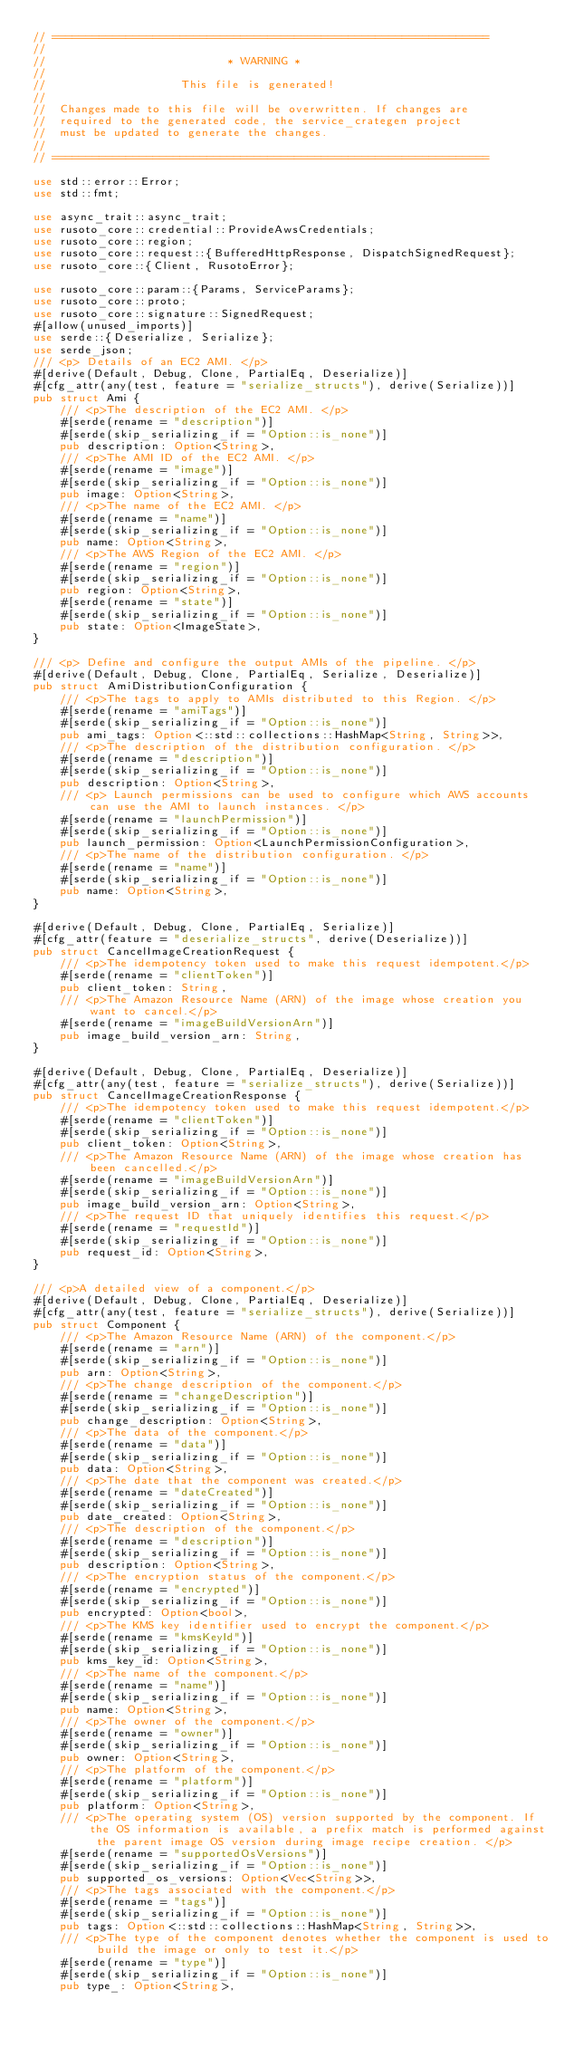<code> <loc_0><loc_0><loc_500><loc_500><_Rust_>// =================================================================
//
//                           * WARNING *
//
//                    This file is generated!
//
//  Changes made to this file will be overwritten. If changes are
//  required to the generated code, the service_crategen project
//  must be updated to generate the changes.
//
// =================================================================

use std::error::Error;
use std::fmt;

use async_trait::async_trait;
use rusoto_core::credential::ProvideAwsCredentials;
use rusoto_core::region;
use rusoto_core::request::{BufferedHttpResponse, DispatchSignedRequest};
use rusoto_core::{Client, RusotoError};

use rusoto_core::param::{Params, ServiceParams};
use rusoto_core::proto;
use rusoto_core::signature::SignedRequest;
#[allow(unused_imports)]
use serde::{Deserialize, Serialize};
use serde_json;
/// <p> Details of an EC2 AMI. </p>
#[derive(Default, Debug, Clone, PartialEq, Deserialize)]
#[cfg_attr(any(test, feature = "serialize_structs"), derive(Serialize))]
pub struct Ami {
    /// <p>The description of the EC2 AMI. </p>
    #[serde(rename = "description")]
    #[serde(skip_serializing_if = "Option::is_none")]
    pub description: Option<String>,
    /// <p>The AMI ID of the EC2 AMI. </p>
    #[serde(rename = "image")]
    #[serde(skip_serializing_if = "Option::is_none")]
    pub image: Option<String>,
    /// <p>The name of the EC2 AMI. </p>
    #[serde(rename = "name")]
    #[serde(skip_serializing_if = "Option::is_none")]
    pub name: Option<String>,
    /// <p>The AWS Region of the EC2 AMI. </p>
    #[serde(rename = "region")]
    #[serde(skip_serializing_if = "Option::is_none")]
    pub region: Option<String>,
    #[serde(rename = "state")]
    #[serde(skip_serializing_if = "Option::is_none")]
    pub state: Option<ImageState>,
}

/// <p> Define and configure the output AMIs of the pipeline. </p>
#[derive(Default, Debug, Clone, PartialEq, Serialize, Deserialize)]
pub struct AmiDistributionConfiguration {
    /// <p>The tags to apply to AMIs distributed to this Region. </p>
    #[serde(rename = "amiTags")]
    #[serde(skip_serializing_if = "Option::is_none")]
    pub ami_tags: Option<::std::collections::HashMap<String, String>>,
    /// <p>The description of the distribution configuration. </p>
    #[serde(rename = "description")]
    #[serde(skip_serializing_if = "Option::is_none")]
    pub description: Option<String>,
    /// <p> Launch permissions can be used to configure which AWS accounts can use the AMI to launch instances. </p>
    #[serde(rename = "launchPermission")]
    #[serde(skip_serializing_if = "Option::is_none")]
    pub launch_permission: Option<LaunchPermissionConfiguration>,
    /// <p>The name of the distribution configuration. </p>
    #[serde(rename = "name")]
    #[serde(skip_serializing_if = "Option::is_none")]
    pub name: Option<String>,
}

#[derive(Default, Debug, Clone, PartialEq, Serialize)]
#[cfg_attr(feature = "deserialize_structs", derive(Deserialize))]
pub struct CancelImageCreationRequest {
    /// <p>The idempotency token used to make this request idempotent.</p>
    #[serde(rename = "clientToken")]
    pub client_token: String,
    /// <p>The Amazon Resource Name (ARN) of the image whose creation you want to cancel.</p>
    #[serde(rename = "imageBuildVersionArn")]
    pub image_build_version_arn: String,
}

#[derive(Default, Debug, Clone, PartialEq, Deserialize)]
#[cfg_attr(any(test, feature = "serialize_structs"), derive(Serialize))]
pub struct CancelImageCreationResponse {
    /// <p>The idempotency token used to make this request idempotent.</p>
    #[serde(rename = "clientToken")]
    #[serde(skip_serializing_if = "Option::is_none")]
    pub client_token: Option<String>,
    /// <p>The Amazon Resource Name (ARN) of the image whose creation has been cancelled.</p>
    #[serde(rename = "imageBuildVersionArn")]
    #[serde(skip_serializing_if = "Option::is_none")]
    pub image_build_version_arn: Option<String>,
    /// <p>The request ID that uniquely identifies this request.</p>
    #[serde(rename = "requestId")]
    #[serde(skip_serializing_if = "Option::is_none")]
    pub request_id: Option<String>,
}

/// <p>A detailed view of a component.</p>
#[derive(Default, Debug, Clone, PartialEq, Deserialize)]
#[cfg_attr(any(test, feature = "serialize_structs"), derive(Serialize))]
pub struct Component {
    /// <p>The Amazon Resource Name (ARN) of the component.</p>
    #[serde(rename = "arn")]
    #[serde(skip_serializing_if = "Option::is_none")]
    pub arn: Option<String>,
    /// <p>The change description of the component.</p>
    #[serde(rename = "changeDescription")]
    #[serde(skip_serializing_if = "Option::is_none")]
    pub change_description: Option<String>,
    /// <p>The data of the component.</p>
    #[serde(rename = "data")]
    #[serde(skip_serializing_if = "Option::is_none")]
    pub data: Option<String>,
    /// <p>The date that the component was created.</p>
    #[serde(rename = "dateCreated")]
    #[serde(skip_serializing_if = "Option::is_none")]
    pub date_created: Option<String>,
    /// <p>The description of the component.</p>
    #[serde(rename = "description")]
    #[serde(skip_serializing_if = "Option::is_none")]
    pub description: Option<String>,
    /// <p>The encryption status of the component.</p>
    #[serde(rename = "encrypted")]
    #[serde(skip_serializing_if = "Option::is_none")]
    pub encrypted: Option<bool>,
    /// <p>The KMS key identifier used to encrypt the component.</p>
    #[serde(rename = "kmsKeyId")]
    #[serde(skip_serializing_if = "Option::is_none")]
    pub kms_key_id: Option<String>,
    /// <p>The name of the component.</p>
    #[serde(rename = "name")]
    #[serde(skip_serializing_if = "Option::is_none")]
    pub name: Option<String>,
    /// <p>The owner of the component.</p>
    #[serde(rename = "owner")]
    #[serde(skip_serializing_if = "Option::is_none")]
    pub owner: Option<String>,
    /// <p>The platform of the component.</p>
    #[serde(rename = "platform")]
    #[serde(skip_serializing_if = "Option::is_none")]
    pub platform: Option<String>,
    /// <p>The operating system (OS) version supported by the component. If the OS information is available, a prefix match is performed against the parent image OS version during image recipe creation. </p>
    #[serde(rename = "supportedOsVersions")]
    #[serde(skip_serializing_if = "Option::is_none")]
    pub supported_os_versions: Option<Vec<String>>,
    /// <p>The tags associated with the component.</p>
    #[serde(rename = "tags")]
    #[serde(skip_serializing_if = "Option::is_none")]
    pub tags: Option<::std::collections::HashMap<String, String>>,
    /// <p>The type of the component denotes whether the component is used to build the image or only to test it.</p>
    #[serde(rename = "type")]
    #[serde(skip_serializing_if = "Option::is_none")]
    pub type_: Option<String>,</code> 